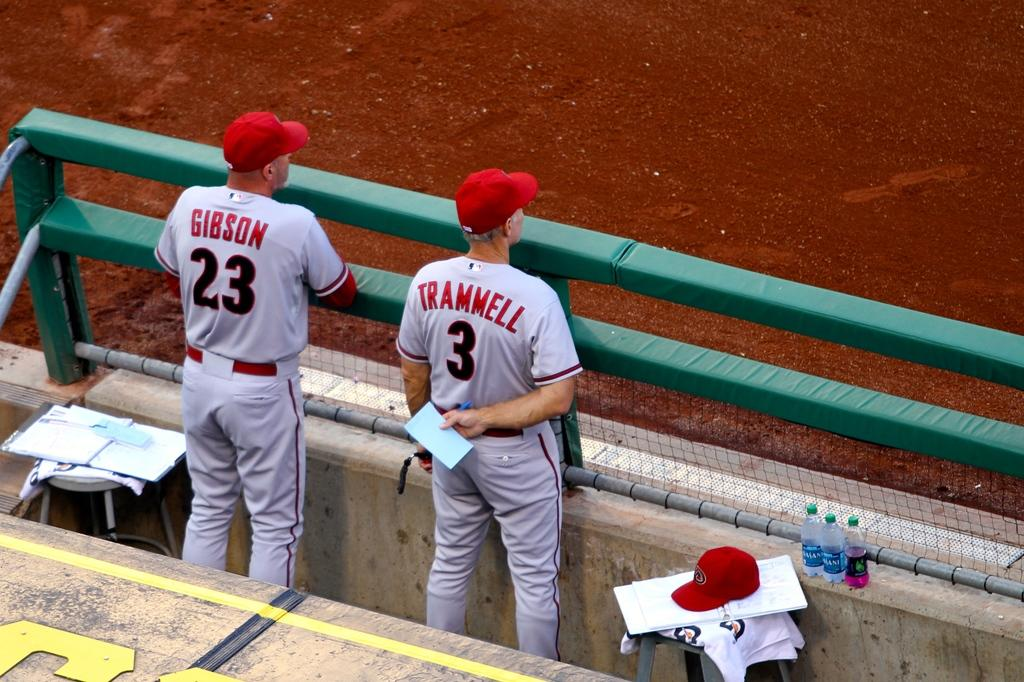<image>
Describe the image concisely. Two baseball players are standing in the dug out and their uniforms say Gibson and Trammell. 